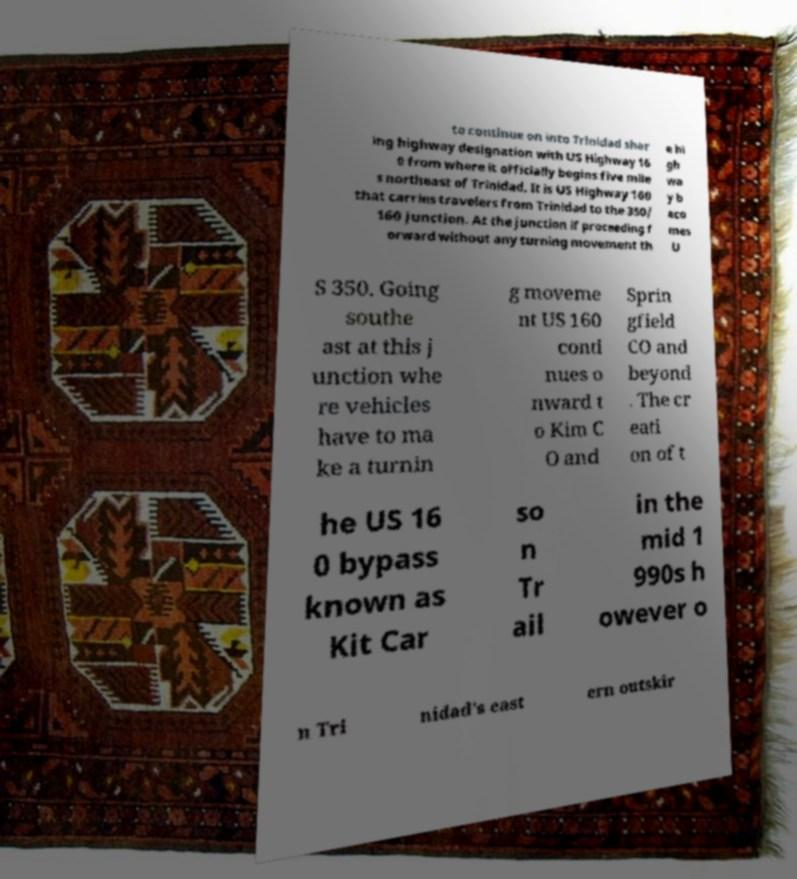There's text embedded in this image that I need extracted. Can you transcribe it verbatim? to continue on into Trinidad shar ing highway designation with US Highway 16 0 from where it officially begins five mile s northeast of Trinidad. It is US Highway 160 that carries travelers from Trinidad to the 350/ 160 junction. At the junction if proceeding f orward without any turning movement th e hi gh wa y b eco mes U S 350. Going southe ast at this j unction whe re vehicles have to ma ke a turnin g moveme nt US 160 conti nues o nward t o Kim C O and Sprin gfield CO and beyond . The cr eati on of t he US 16 0 bypass known as Kit Car so n Tr ail in the mid 1 990s h owever o n Tri nidad's east ern outskir 